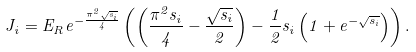<formula> <loc_0><loc_0><loc_500><loc_500>J _ { i } = E _ { R } e ^ { - \frac { \pi ^ { 2 } \sqrt { s _ { i } } } { 4 } } \left ( \left ( \frac { \pi ^ { 2 } s _ { i } } { 4 } - \frac { \sqrt { s _ { i } } } { 2 } \right ) - \frac { 1 } { 2 } s _ { i } \left ( 1 + e ^ { - \sqrt { s _ { i } } } \right ) \right ) .</formula> 